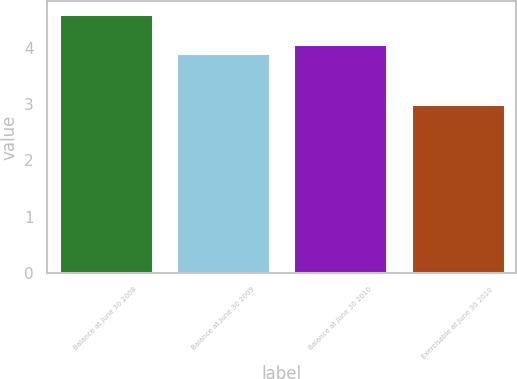<chart> <loc_0><loc_0><loc_500><loc_500><bar_chart><fcel>Balance at June 30 2008<fcel>Balance at June 30 2009<fcel>Balance at June 30 2010<fcel>Exercisable at June 30 2010<nl><fcel>4.6<fcel>3.9<fcel>4.06<fcel>3<nl></chart> 